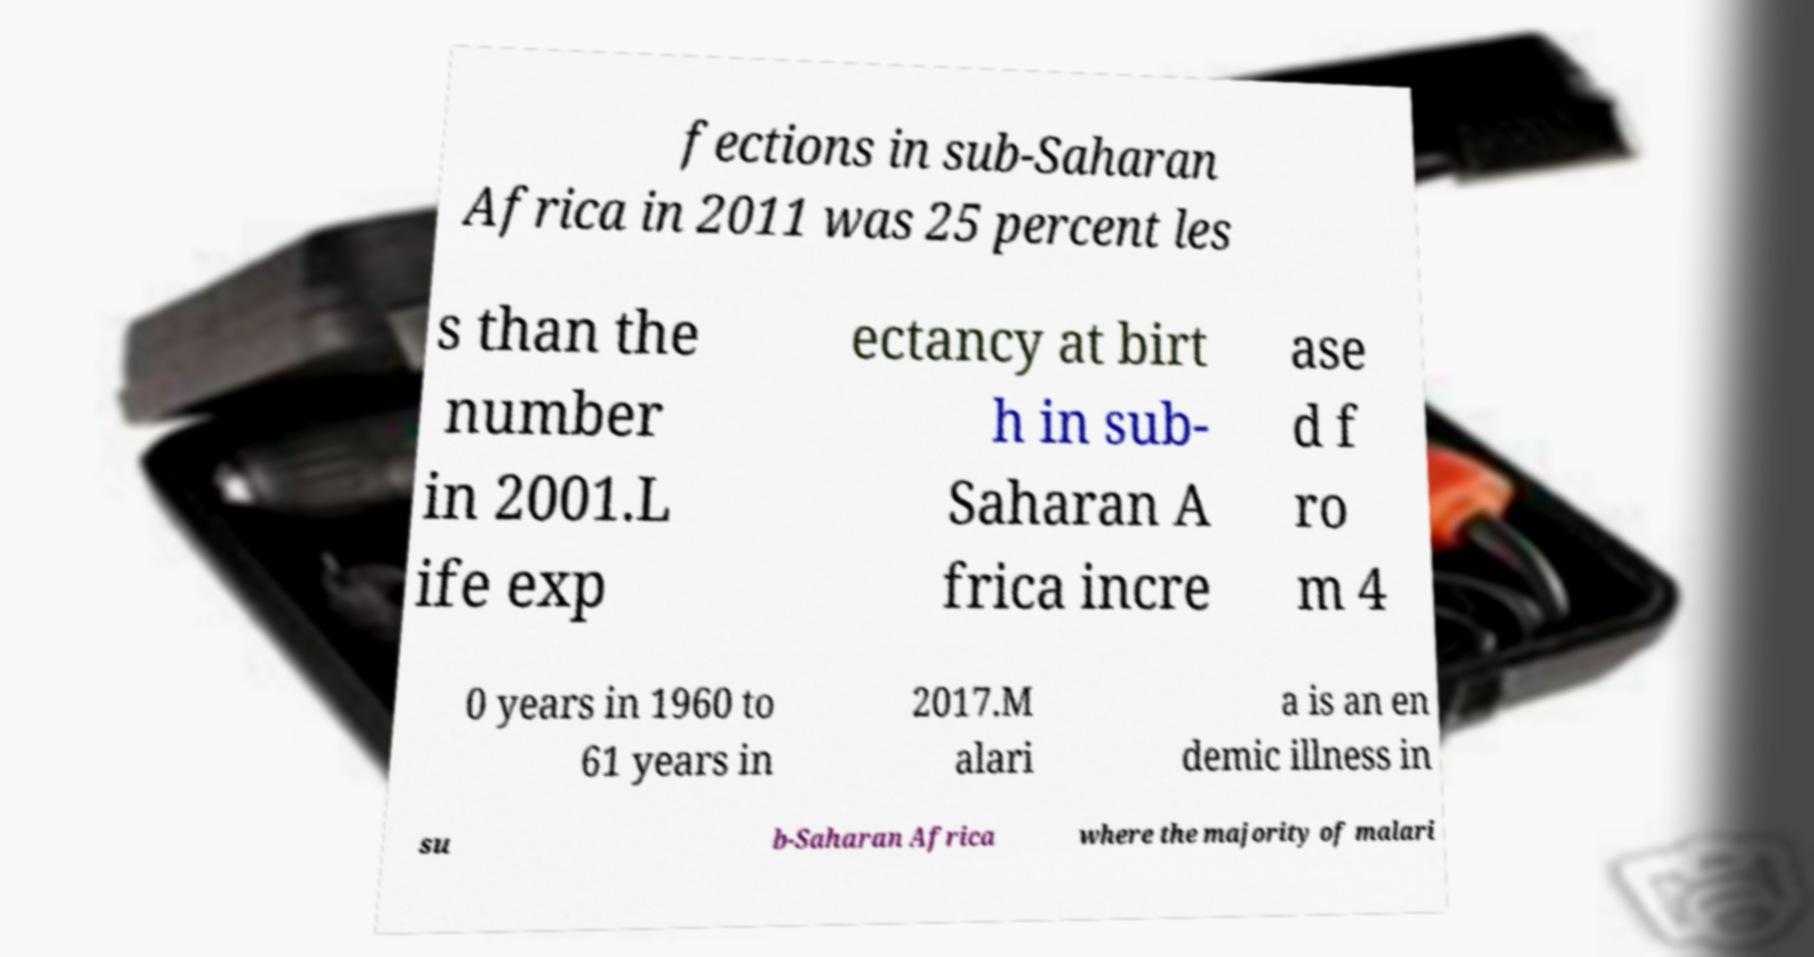For documentation purposes, I need the text within this image transcribed. Could you provide that? fections in sub-Saharan Africa in 2011 was 25 percent les s than the number in 2001.L ife exp ectancy at birt h in sub- Saharan A frica incre ase d f ro m 4 0 years in 1960 to 61 years in 2017.M alari a is an en demic illness in su b-Saharan Africa where the majority of malari 